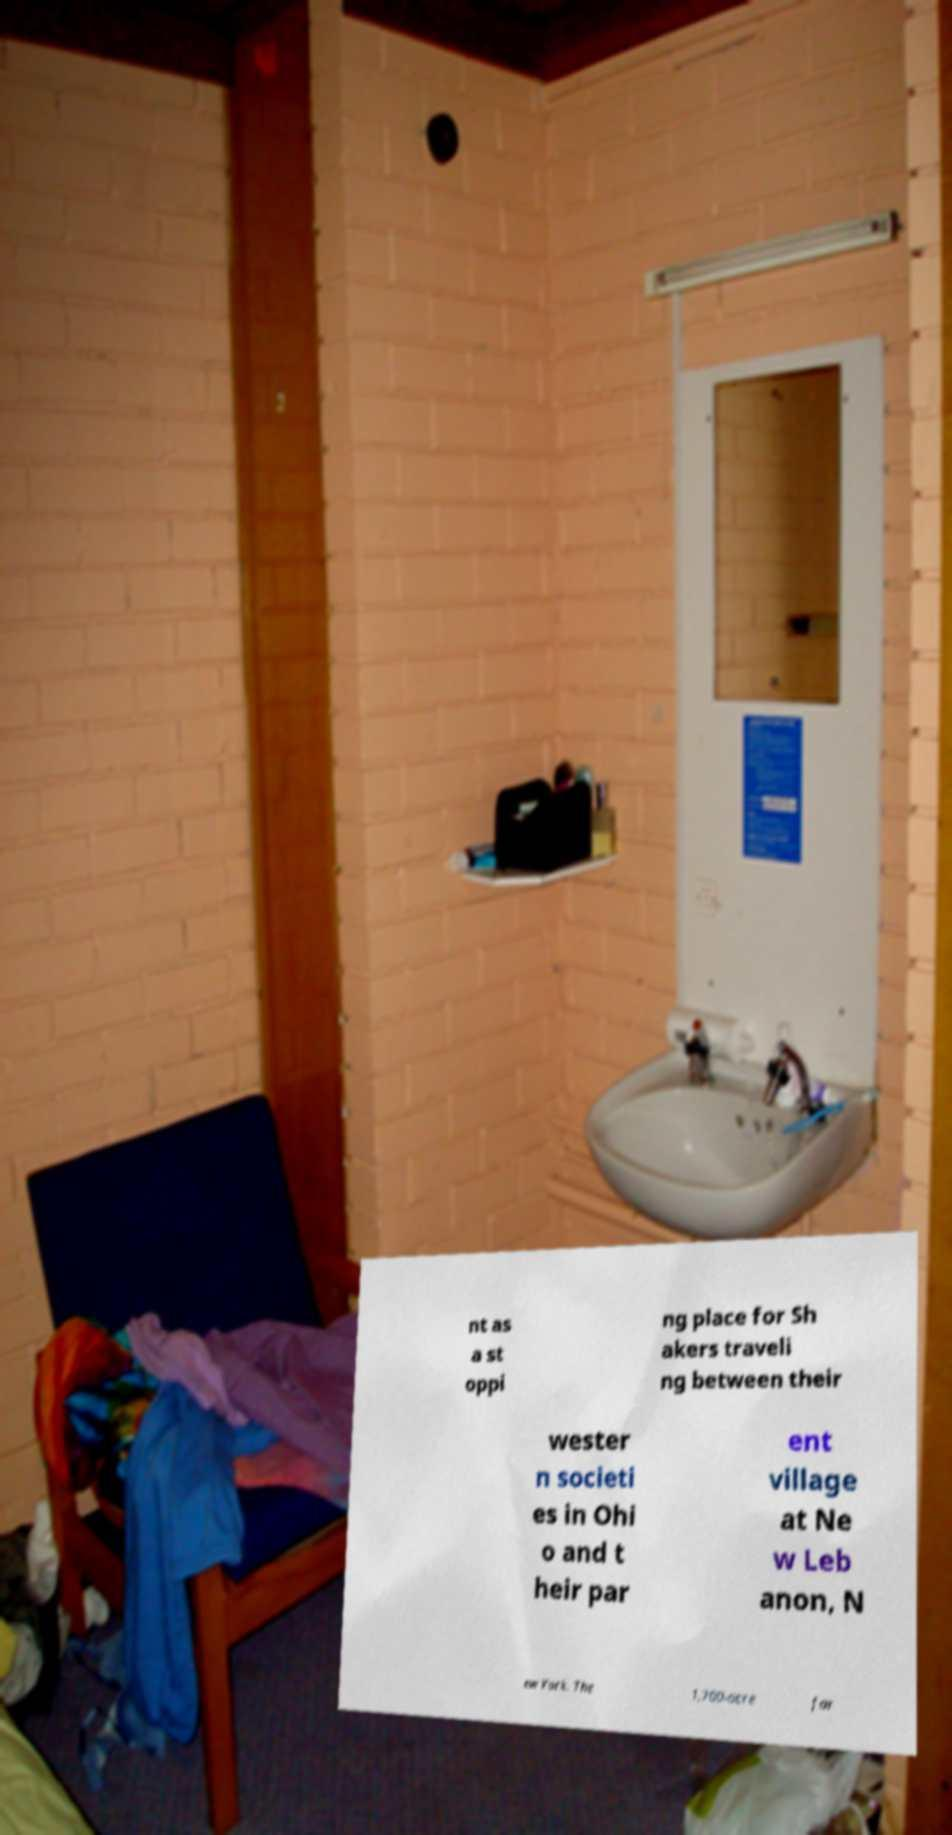Could you extract and type out the text from this image? nt as a st oppi ng place for Sh akers traveli ng between their wester n societi es in Ohi o and t heir par ent village at Ne w Leb anon, N ew York. The 1,700-acre far 